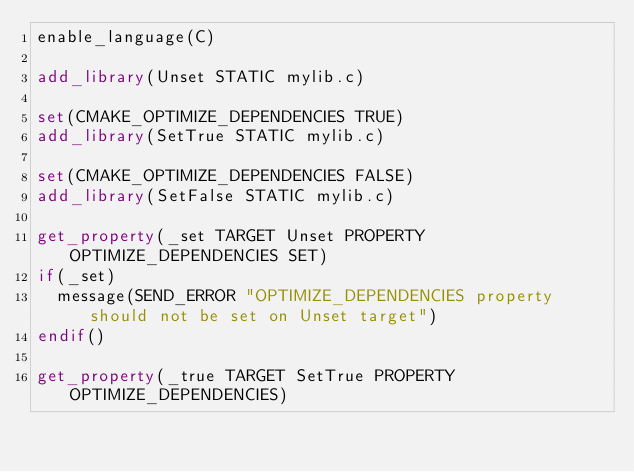Convert code to text. <code><loc_0><loc_0><loc_500><loc_500><_CMake_>enable_language(C)

add_library(Unset STATIC mylib.c)

set(CMAKE_OPTIMIZE_DEPENDENCIES TRUE)
add_library(SetTrue STATIC mylib.c)

set(CMAKE_OPTIMIZE_DEPENDENCIES FALSE)
add_library(SetFalse STATIC mylib.c)

get_property(_set TARGET Unset PROPERTY OPTIMIZE_DEPENDENCIES SET)
if(_set)
  message(SEND_ERROR "OPTIMIZE_DEPENDENCIES property should not be set on Unset target")
endif()

get_property(_true TARGET SetTrue PROPERTY OPTIMIZE_DEPENDENCIES)</code> 